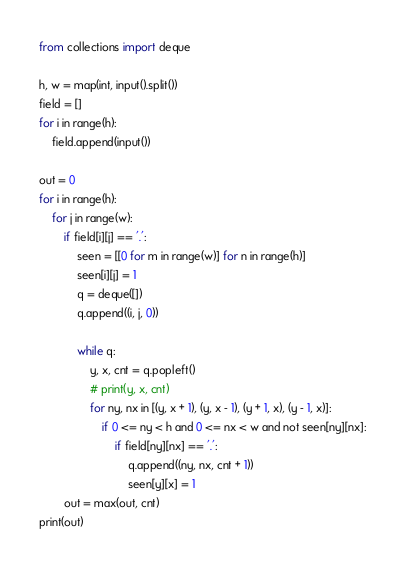Convert code to text. <code><loc_0><loc_0><loc_500><loc_500><_Python_>from collections import deque

h, w = map(int, input().split())
field = []
for i in range(h):
    field.append(input())

out = 0
for i in range(h):
    for j in range(w):
        if field[i][j] == '.':
            seen = [[0 for m in range(w)] for n in range(h)]
            seen[i][j] = 1
            q = deque([])
            q.append((i, j, 0))

            while q:
                y, x, cnt = q.popleft()
                # print(y, x, cnt)
                for ny, nx in [(y, x + 1), (y, x - 1), (y + 1, x), (y - 1, x)]:
                    if 0 <= ny < h and 0 <= nx < w and not seen[ny][nx]:
                        if field[ny][nx] == '.':
                            q.append((ny, nx, cnt + 1))
                            seen[y][x] = 1
        out = max(out, cnt)
print(out)
</code> 